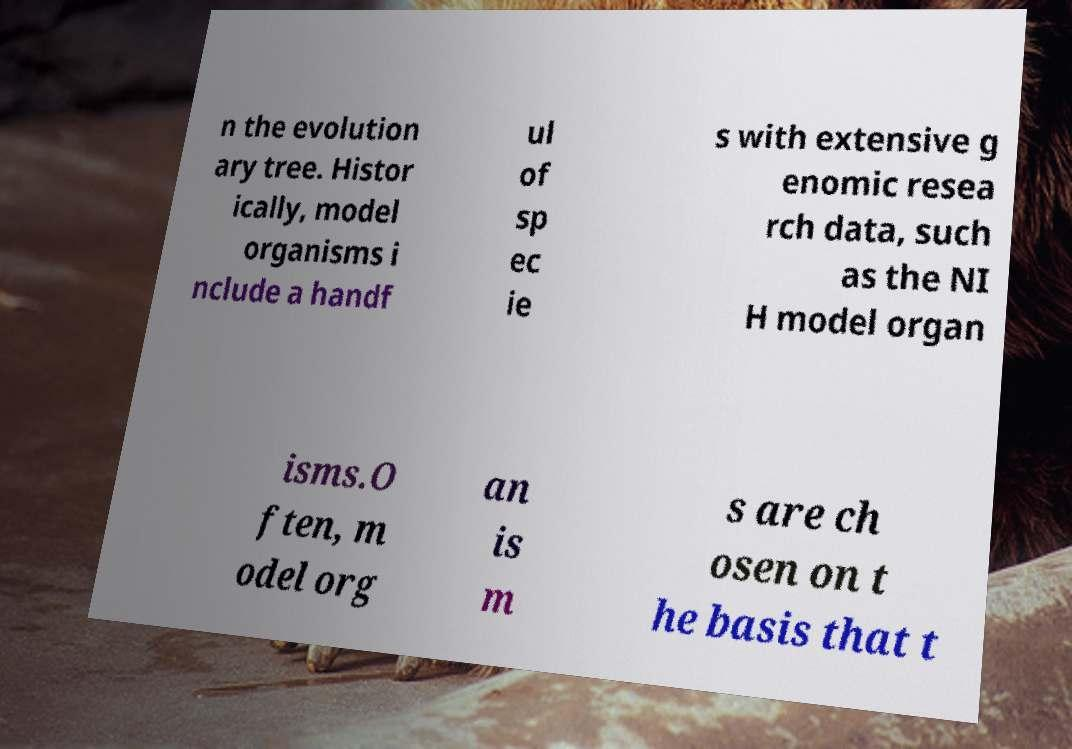Could you extract and type out the text from this image? n the evolution ary tree. Histor ically, model organisms i nclude a handf ul of sp ec ie s with extensive g enomic resea rch data, such as the NI H model organ isms.O ften, m odel org an is m s are ch osen on t he basis that t 